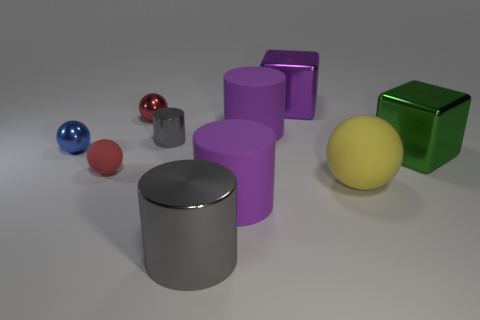Is the purple cylinder in front of the yellow matte thing made of the same material as the gray object in front of the large ball?
Your answer should be very brief. No. The tiny gray thing that is behind the rubber thing that is to the left of the tiny gray metallic cylinder is what shape?
Keep it short and to the point. Cylinder. Are there fewer blue objects than gray things?
Your answer should be compact. Yes. What color is the big metal thing behind the large green shiny object?
Your answer should be very brief. Purple. What is the sphere that is both right of the small red rubber sphere and left of the large purple metal thing made of?
Keep it short and to the point. Metal. What shape is the red object that is made of the same material as the big ball?
Offer a terse response. Sphere. There is a big purple cylinder behind the blue object; how many small blue shiny objects are behind it?
Your response must be concise. 0. What number of tiny red balls are in front of the small gray cylinder and behind the green thing?
Offer a terse response. 0. How many other things are there of the same material as the small blue object?
Your answer should be compact. 5. What is the color of the big rubber cylinder behind the purple cylinder that is in front of the tiny blue metallic sphere?
Your answer should be very brief. Purple. 